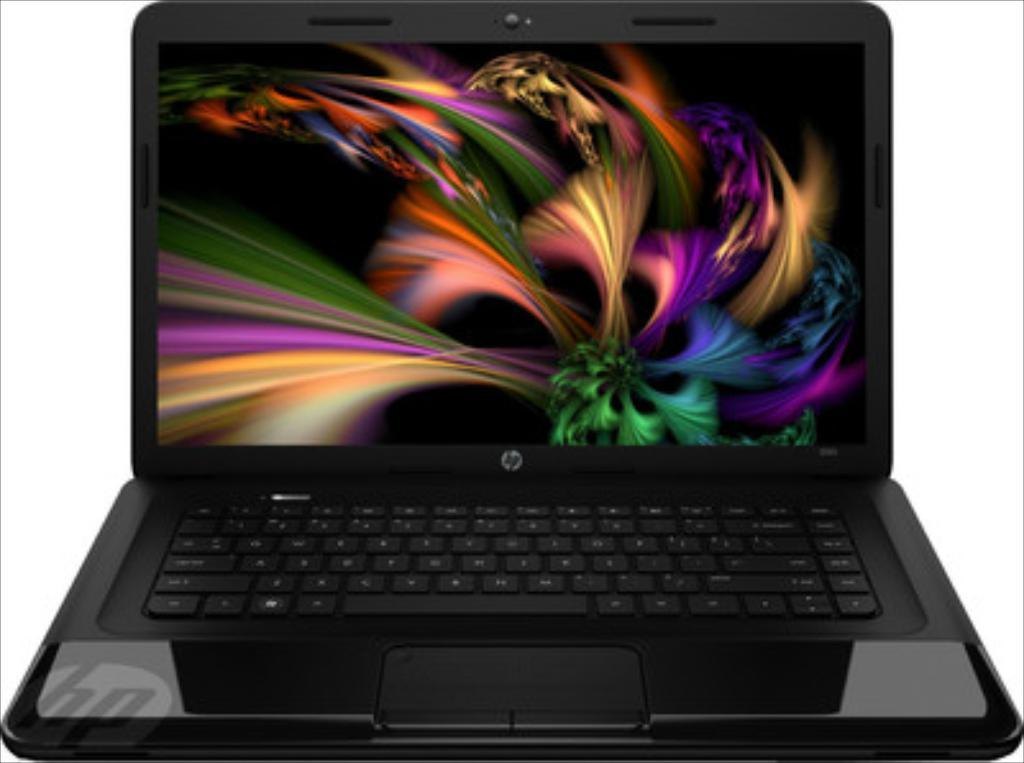What is the main object in the center of the image? There is a laptop in the center of the image. Can you describe the laptop's position in the image? The laptop is in the center of the image. What might the laptop be used for in the image? The laptop could be used for various purposes, such as browsing the internet, working on documents, or streaming media. What type of cushion is placed on the laptop in the image? There is no cushion present on the laptop in the image. How does the laptop control the spring in the image? There is no spring present in the image, and therefore the laptop cannot control it. 